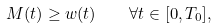Convert formula to latex. <formula><loc_0><loc_0><loc_500><loc_500>M ( t ) \geq w ( t ) \quad \forall t \in [ 0 , T _ { 0 } ] ,</formula> 